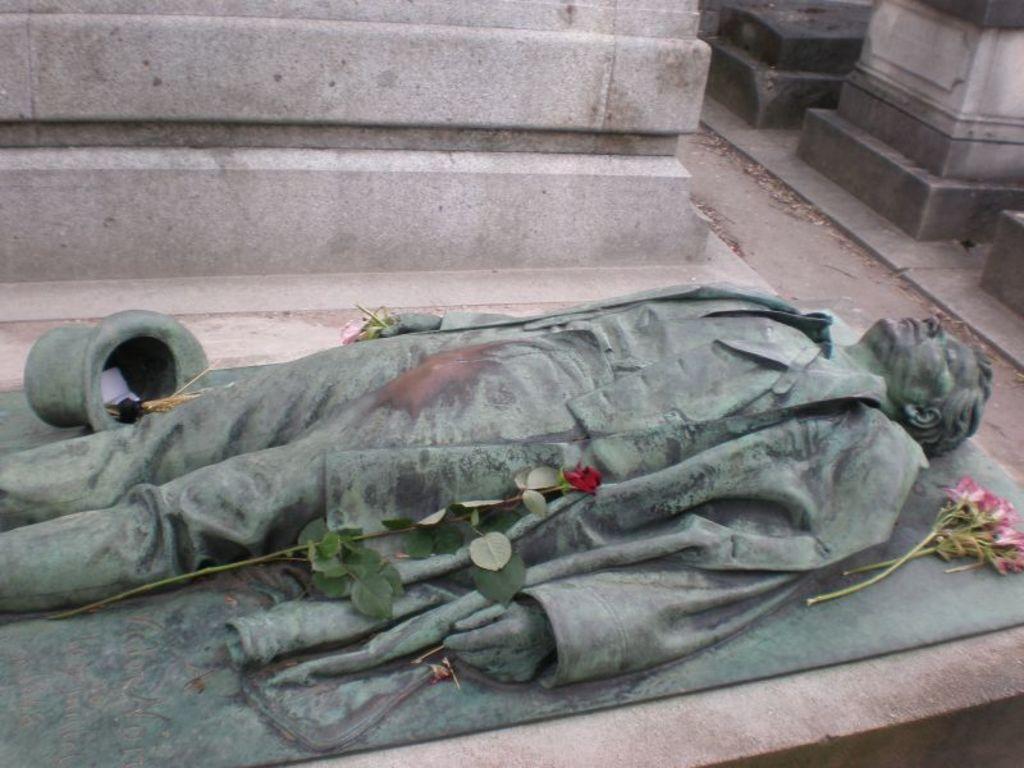Please provide a concise description of this image. Here we can see a sculpture and there are flowers. 